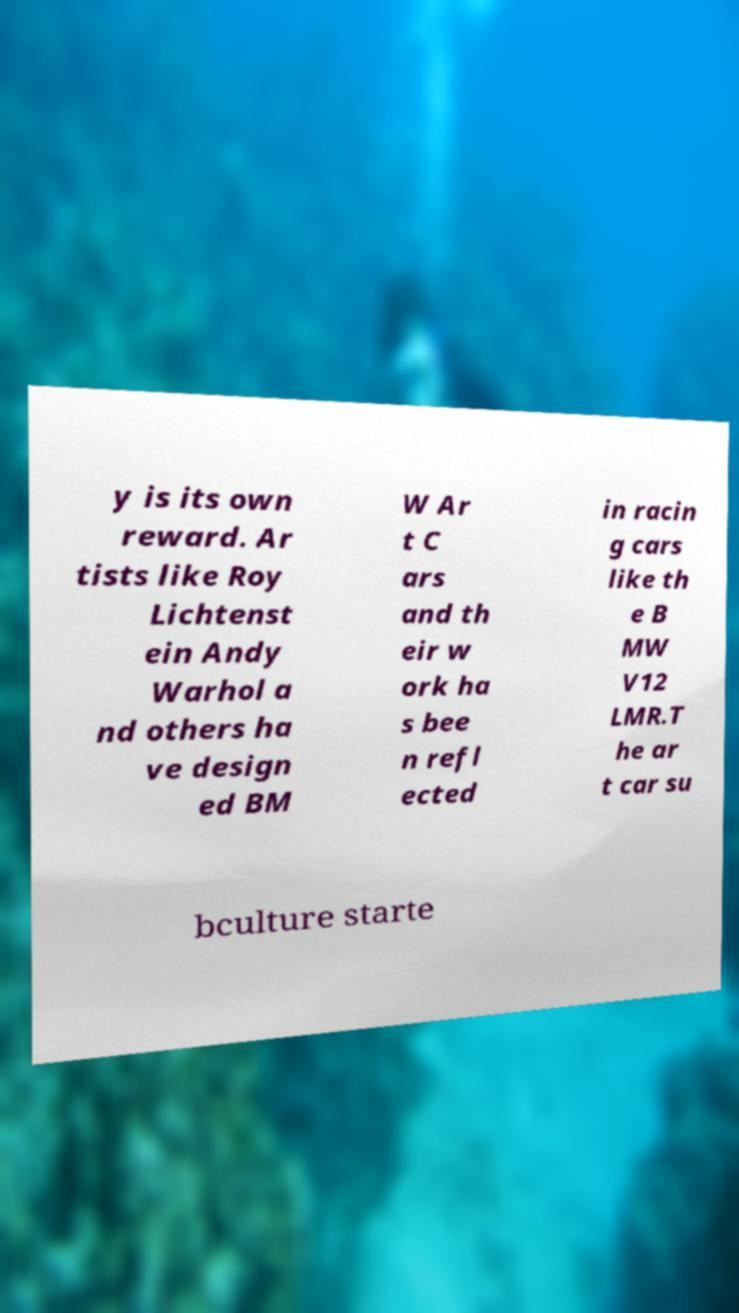Can you read and provide the text displayed in the image?This photo seems to have some interesting text. Can you extract and type it out for me? y is its own reward. Ar tists like Roy Lichtenst ein Andy Warhol a nd others ha ve design ed BM W Ar t C ars and th eir w ork ha s bee n refl ected in racin g cars like th e B MW V12 LMR.T he ar t car su bculture starte 